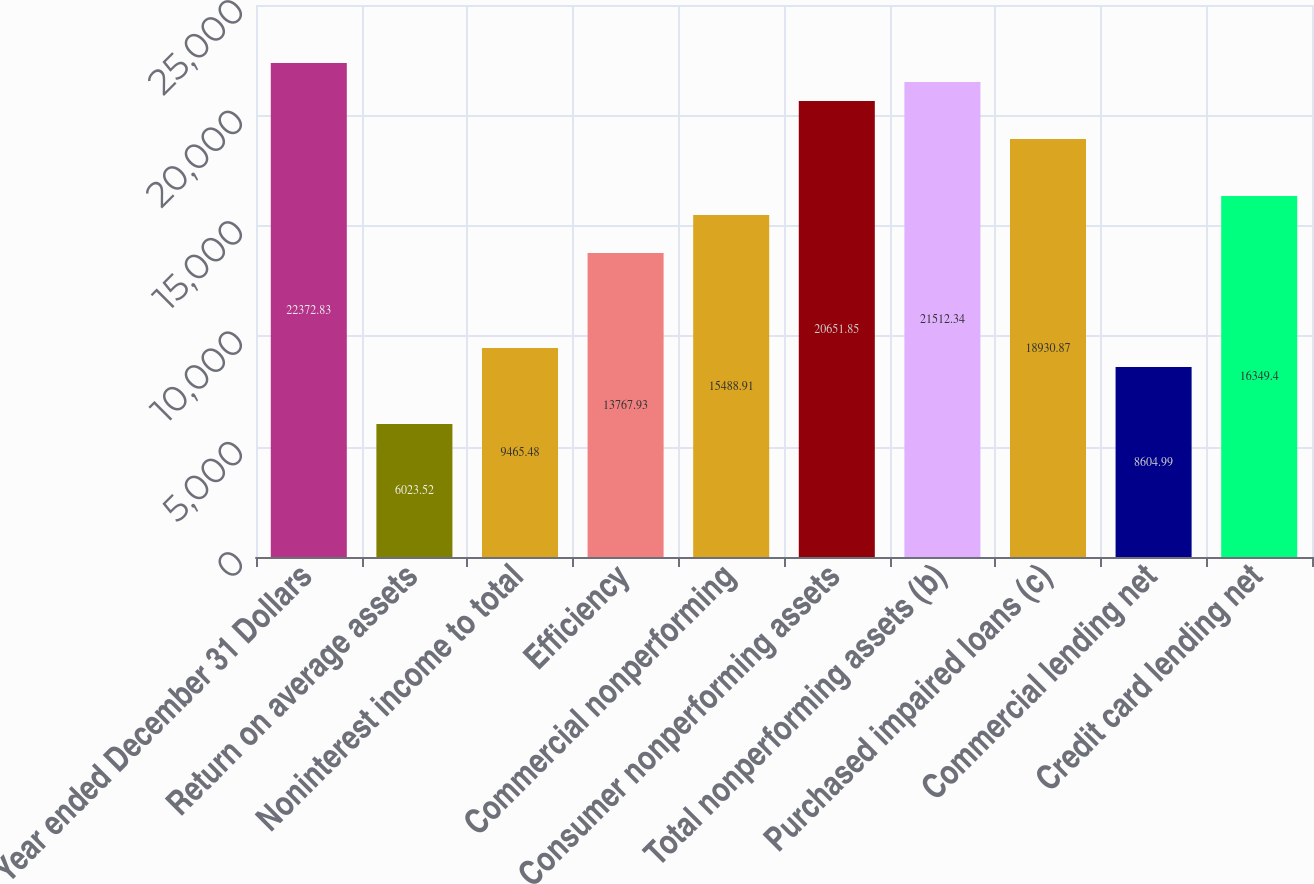<chart> <loc_0><loc_0><loc_500><loc_500><bar_chart><fcel>Year ended December 31 Dollars<fcel>Return on average assets<fcel>Noninterest income to total<fcel>Efficiency<fcel>Commercial nonperforming<fcel>Consumer nonperforming assets<fcel>Total nonperforming assets (b)<fcel>Purchased impaired loans (c)<fcel>Commercial lending net<fcel>Credit card lending net<nl><fcel>22372.8<fcel>6023.52<fcel>9465.48<fcel>13767.9<fcel>15488.9<fcel>20651.8<fcel>21512.3<fcel>18930.9<fcel>8604.99<fcel>16349.4<nl></chart> 